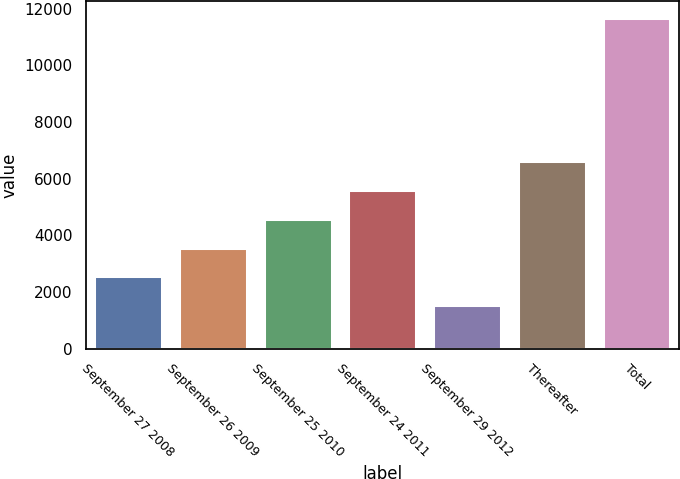<chart> <loc_0><loc_0><loc_500><loc_500><bar_chart><fcel>September 27 2008<fcel>September 26 2009<fcel>September 25 2010<fcel>September 24 2011<fcel>September 29 2012<fcel>Thereafter<fcel>Total<nl><fcel>2554.6<fcel>3568.2<fcel>4581.8<fcel>5595.4<fcel>1541<fcel>6609<fcel>11677<nl></chart> 